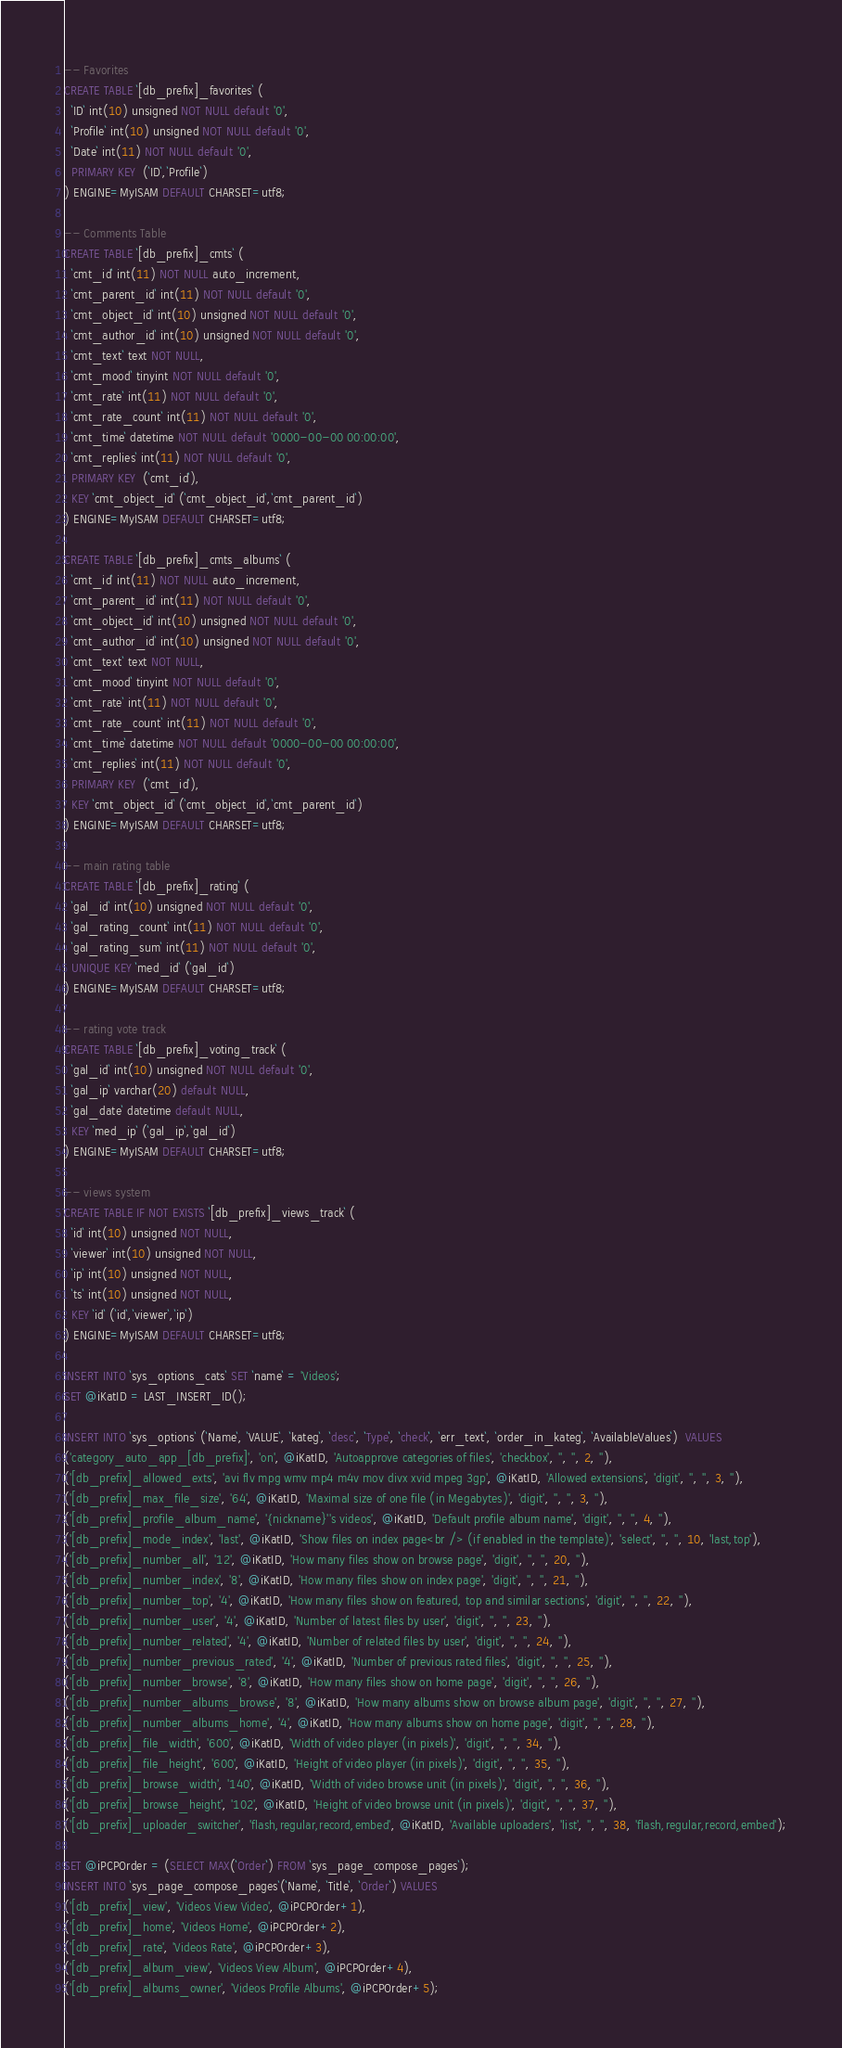Convert code to text. <code><loc_0><loc_0><loc_500><loc_500><_SQL_>-- Favorites
CREATE TABLE `[db_prefix]_favorites` (
  `ID` int(10) unsigned NOT NULL default '0',
  `Profile` int(10) unsigned NOT NULL default '0',
  `Date` int(11) NOT NULL default '0',
  PRIMARY KEY  (`ID`,`Profile`)
) ENGINE=MyISAM DEFAULT CHARSET=utf8;

-- Comments Table
CREATE TABLE `[db_prefix]_cmts` (
  `cmt_id` int(11) NOT NULL auto_increment,
  `cmt_parent_id` int(11) NOT NULL default '0',
  `cmt_object_id` int(10) unsigned NOT NULL default '0',
  `cmt_author_id` int(10) unsigned NOT NULL default '0',
  `cmt_text` text NOT NULL,
  `cmt_mood` tinyint NOT NULL default '0',
  `cmt_rate` int(11) NOT NULL default '0',
  `cmt_rate_count` int(11) NOT NULL default '0',
  `cmt_time` datetime NOT NULL default '0000-00-00 00:00:00',
  `cmt_replies` int(11) NOT NULL default '0',
  PRIMARY KEY  (`cmt_id`),
  KEY `cmt_object_id` (`cmt_object_id`,`cmt_parent_id`)
) ENGINE=MyISAM DEFAULT CHARSET=utf8;

CREATE TABLE `[db_prefix]_cmts_albums` (
  `cmt_id` int(11) NOT NULL auto_increment,
  `cmt_parent_id` int(11) NOT NULL default '0',
  `cmt_object_id` int(10) unsigned NOT NULL default '0',
  `cmt_author_id` int(10) unsigned NOT NULL default '0',
  `cmt_text` text NOT NULL,
  `cmt_mood` tinyint NOT NULL default '0',
  `cmt_rate` int(11) NOT NULL default '0',
  `cmt_rate_count` int(11) NOT NULL default '0',
  `cmt_time` datetime NOT NULL default '0000-00-00 00:00:00',
  `cmt_replies` int(11) NOT NULL default '0',
  PRIMARY KEY  (`cmt_id`),
  KEY `cmt_object_id` (`cmt_object_id`,`cmt_parent_id`)
) ENGINE=MyISAM DEFAULT CHARSET=utf8;

-- main rating table
CREATE TABLE `[db_prefix]_rating` (
  `gal_id` int(10) unsigned NOT NULL default '0',
  `gal_rating_count` int(11) NOT NULL default '0',
  `gal_rating_sum` int(11) NOT NULL default '0',
  UNIQUE KEY `med_id` (`gal_id`)
) ENGINE=MyISAM DEFAULT CHARSET=utf8;

-- rating vote track
CREATE TABLE `[db_prefix]_voting_track` (
  `gal_id` int(10) unsigned NOT NULL default '0',
  `gal_ip` varchar(20) default NULL,
  `gal_date` datetime default NULL,
  KEY `med_ip` (`gal_ip`,`gal_id`)
) ENGINE=MyISAM DEFAULT CHARSET=utf8;

-- views system
CREATE TABLE IF NOT EXISTS `[db_prefix]_views_track` (
  `id` int(10) unsigned NOT NULL,
  `viewer` int(10) unsigned NOT NULL,
  `ip` int(10) unsigned NOT NULL,
  `ts` int(10) unsigned NOT NULL,
  KEY `id` (`id`,`viewer`,`ip`)
) ENGINE=MyISAM DEFAULT CHARSET=utf8;

INSERT INTO `sys_options_cats` SET `name` = 'Videos';
SET @iKatID = LAST_INSERT_ID();

INSERT INTO `sys_options` (`Name`, `VALUE`, `kateg`, `desc`, `Type`, `check`, `err_text`, `order_in_kateg`, `AvailableValues`)  VALUES
('category_auto_app_[db_prefix]', 'on', @iKatID, 'Autoapprove categories of files', 'checkbox', '', '', 2, ''),
('[db_prefix]_allowed_exts', 'avi flv mpg wmv mp4 m4v mov divx xvid mpeg 3gp', @iKatID, 'Allowed extensions', 'digit', '', '', 3, ''),
('[db_prefix]_max_file_size', '64', @iKatID, 'Maximal size of one file (in Megabytes)', 'digit', '', '', 3, ''),
('[db_prefix]_profile_album_name', '{nickname}''s videos', @iKatID, 'Default profile album name', 'digit', '', '', 4, ''),
('[db_prefix]_mode_index', 'last', @iKatID, 'Show files on index page<br /> (if enabled in the template)', 'select', '', '', 10, 'last,top'),
('[db_prefix]_number_all', '12', @iKatID, 'How many files show on browse page', 'digit', '', '', 20, ''),
('[db_prefix]_number_index', '8', @iKatID, 'How many files show on index page', 'digit', '', '', 21, ''),
('[db_prefix]_number_top', '4', @iKatID, 'How many files show on featured, top and similar sections', 'digit', '', '', 22, ''),
('[db_prefix]_number_user', '4', @iKatID, 'Number of latest files by user', 'digit', '', '', 23, ''),
('[db_prefix]_number_related', '4', @iKatID, 'Number of related files by user', 'digit', '', '', 24, ''),
('[db_prefix]_number_previous_rated', '4', @iKatID, 'Number of previous rated files', 'digit', '', '', 25, ''),
('[db_prefix]_number_browse', '8', @iKatID, 'How many files show on home page', 'digit', '', '', 26, ''),
('[db_prefix]_number_albums_browse', '8', @iKatID, 'How many albums show on browse album page', 'digit', '', '', 27, ''),
('[db_prefix]_number_albums_home', '4', @iKatID, 'How many albums show on home page', 'digit', '', '', 28, ''),
('[db_prefix]_file_width', '600', @iKatID, 'Width of video player (in pixels)', 'digit', '', '', 34, ''),
('[db_prefix]_file_height', '600', @iKatID, 'Height of video player (in pixels)', 'digit', '', '', 35, ''),
('[db_prefix]_browse_width', '140', @iKatID, 'Width of video browse unit (in pixels)', 'digit', '', '', 36, ''),
('[db_prefix]_browse_height', '102', @iKatID, 'Height of video browse unit (in pixels)', 'digit', '', '', 37, ''),
('[db_prefix]_uploader_switcher', 'flash,regular,record,embed', @iKatID, 'Available uploaders', 'list', '', '', 38, 'flash,regular,record,embed');

SET @iPCPOrder = (SELECT MAX(`Order`) FROM `sys_page_compose_pages`);
INSERT INTO `sys_page_compose_pages`(`Name`, `Title`, `Order`) VALUES 
('[db_prefix]_view', 'Videos View Video', @iPCPOrder+1),
('[db_prefix]_home', 'Videos Home', @iPCPOrder+2),
('[db_prefix]_rate', 'Videos Rate', @iPCPOrder+3),
('[db_prefix]_album_view', 'Videos View Album', @iPCPOrder+4),
('[db_prefix]_albums_owner', 'Videos Profile Albums', @iPCPOrder+5);
</code> 